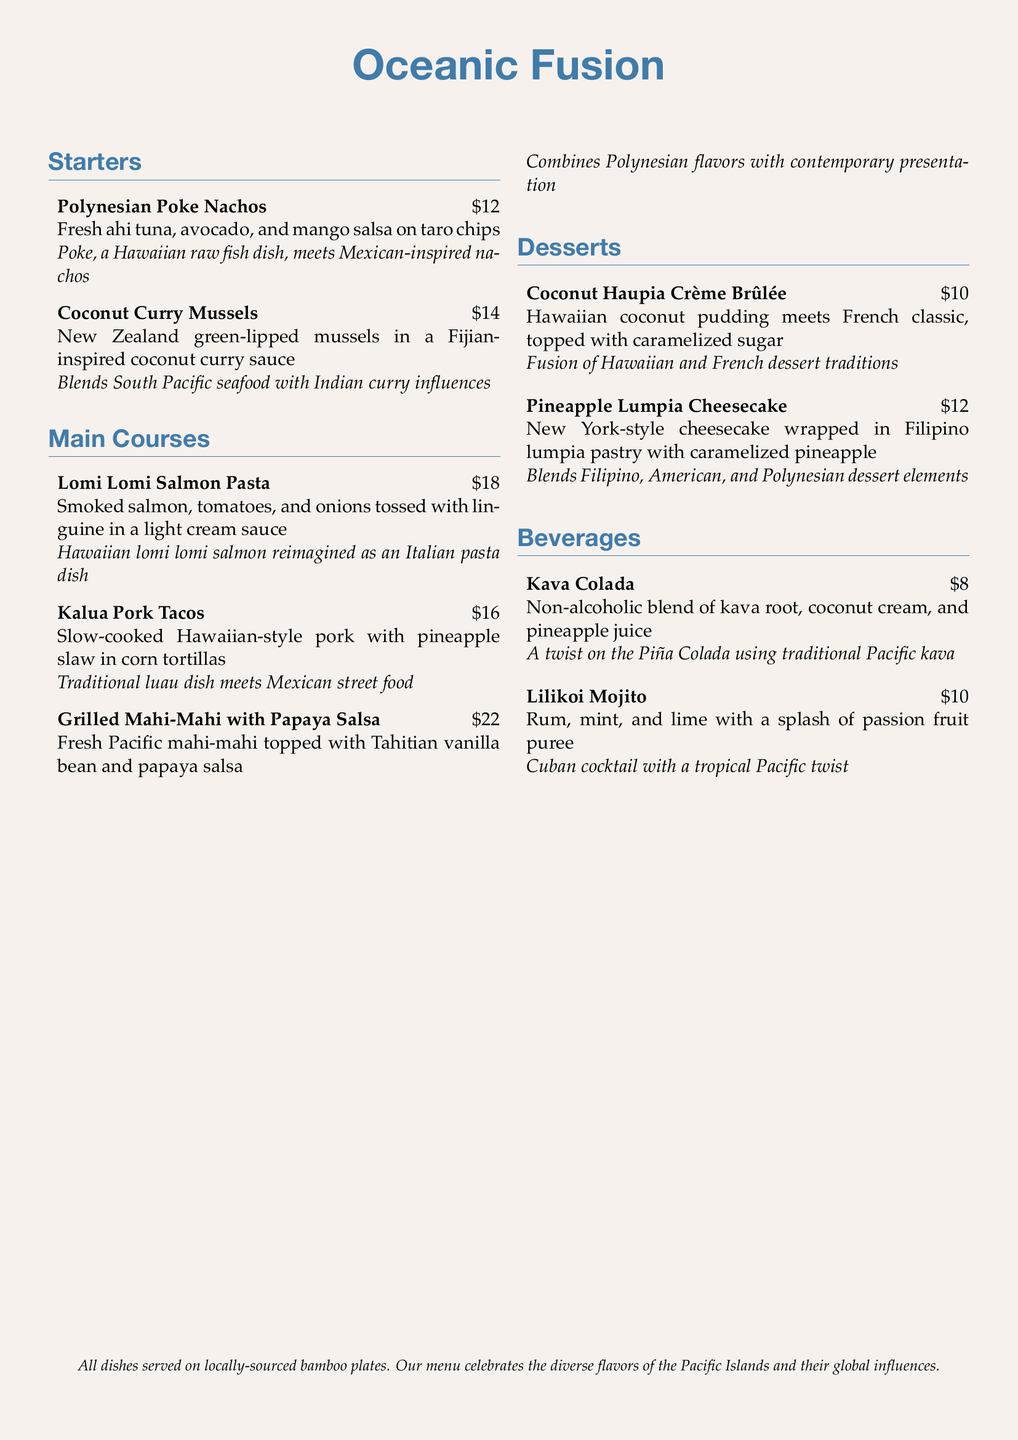What is the price of Polynesian Poke Nachos? The price of Polynesian Poke Nachos is stated directly in the menu.
Answer: $12 What type of cuisine influences the Coconut Curry Mussels? The menu provides a cultural explanation that identifies Indian cuisine as the influence.
Answer: Indian How is the Lomi Lomi Salmon Pasta reimagined? The description highlights its transformation from a Hawaiian dish to an Italian pasta dish.
Answer: Italian What beverage uses kava root? The menu lists the Kava Colada as the drink incorporating kava root.
Answer: Kava Colada How many main courses are listed in the menu? The menu enumerates the main courses, revealing there are three distinct dishes.
Answer: 3 Which dessert combines Hawaiian and French traditions? The menu explains that the Coconut Haupia Crème Brûlée merges elements from both cultures.
Answer: Coconut Haupia Crème Brûlée What is the primary fish in the Grilled Mahi-Mahi dish? The menu specifies mahi-mahi as the main fish served.
Answer: Mahi-Mahi Which dessert features caramelized pineapple? The menu mentions that the Pineapple Lumpia Cheesecake includes caramelized pineapple.
Answer: Pineapple Lumpia Cheesecake What is the price of the Lilikoi Mojito? The pricing information for the Lilikoi Mojito is explicitly mentioned in the menu.
Answer: $10 